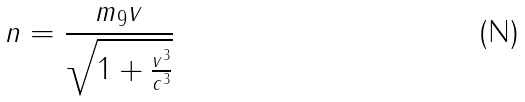<formula> <loc_0><loc_0><loc_500><loc_500>n = \frac { m _ { 9 } v } { \sqrt { 1 + \frac { v ^ { 3 } } { c ^ { 3 } } } }</formula> 